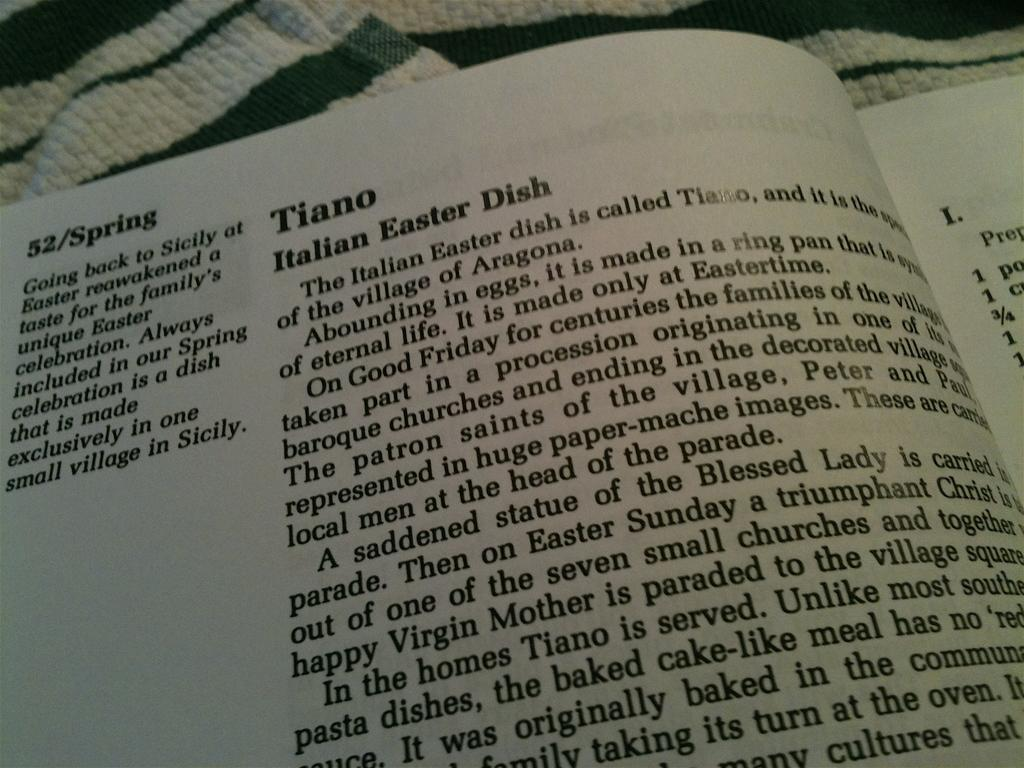<image>
Provide a brief description of the given image. a book that says 'tiano italian easter dish' on it 